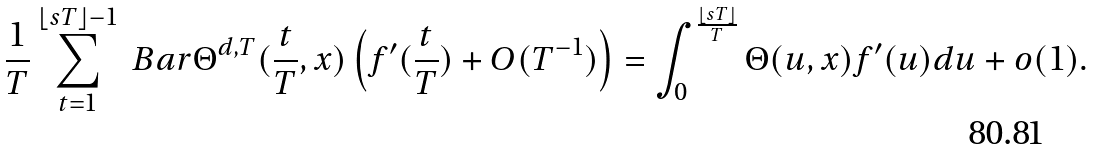Convert formula to latex. <formula><loc_0><loc_0><loc_500><loc_500>\frac { 1 } { T } \sum _ { t = 1 } ^ { \lfloor s T \rfloor - 1 } \ B a r { \Theta } ^ { d , T } ( \frac { t } { T } , x ) \left ( f ^ { \prime } ( \frac { t } { T } ) + O ( T ^ { - 1 } ) \right ) = \int _ { 0 } ^ { \frac { \lfloor s T \rfloor } { T } } \Theta ( u , x ) f ^ { \prime } ( u ) d u + o ( 1 ) .</formula> 